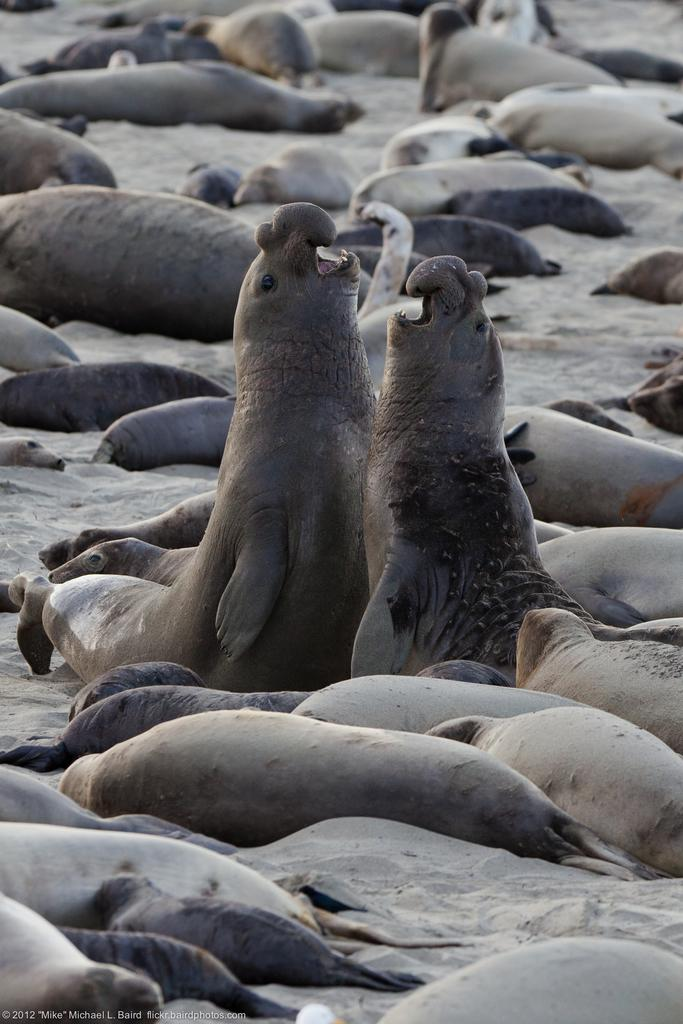What type of animals are present in the image? There are elephant seals in the image. What type of flower can be seen growing near the mine in the image? There is no flower or mine present in the image; it features elephant seals. How many frogs are visible on the elephant seals in the image? There are no frogs present on the elephant seals in the image. 